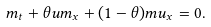<formula> <loc_0><loc_0><loc_500><loc_500>m _ { t } + \theta u m _ { x } + ( 1 - \theta ) m u _ { x } = 0 .</formula> 